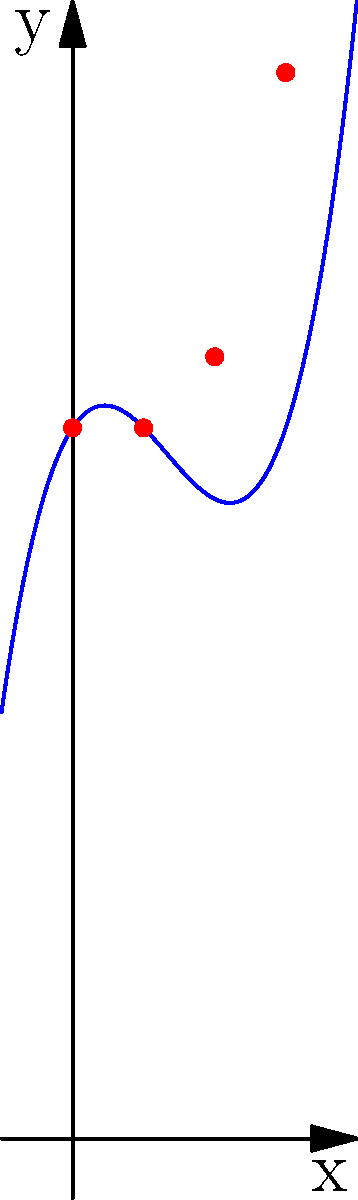As part of a legacy system modernization project, you're analyzing historical data on system performance. The scatter plot shows actual data points, and the blue curve represents a polynomial regression model. Given that the model is of the form $f(x) = ax^3 + bx^2 + cx + d$, what is the value of $d$ in this polynomial function? To find the value of $d$ in the polynomial function $f(x) = ax^3 + bx^2 + cx + d$, we need to analyze the graph:

1. The polynomial function is of degree 3, as evident from the curve's shape.
2. The $d$ term represents the y-intercept of the function, which is the point where the curve intersects the y-axis.
3. From the graph, we can see that the curve intersects the y-axis at the point (0, 10).
4. Therefore, when $x = 0$, $f(0) = d = 10$.

This means that regardless of the values of $a$, $b$, and $c$, the constant term $d$ in the polynomial function must be 10 to make the curve pass through the point (0, 10) on the y-axis.
Answer: 10 